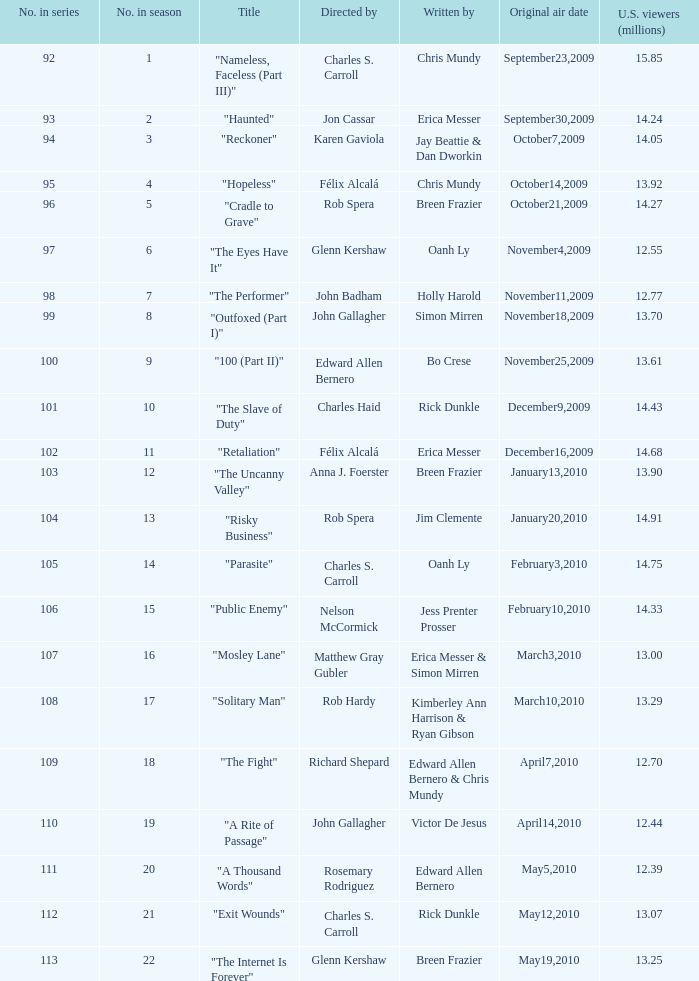What was the original air date for the episode with 13.92 million us viewers? October14,2009. 